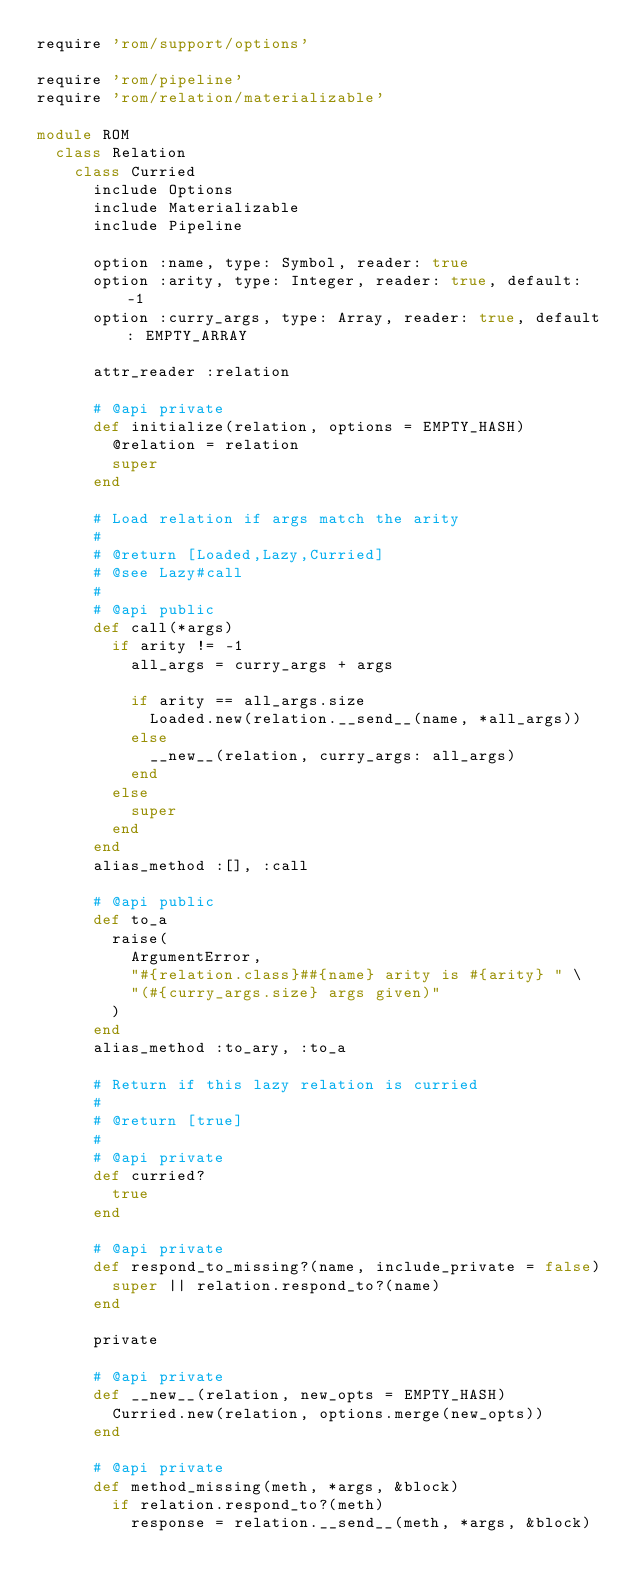<code> <loc_0><loc_0><loc_500><loc_500><_Ruby_>require 'rom/support/options'

require 'rom/pipeline'
require 'rom/relation/materializable'

module ROM
  class Relation
    class Curried
      include Options
      include Materializable
      include Pipeline

      option :name, type: Symbol, reader: true
      option :arity, type: Integer, reader: true, default: -1
      option :curry_args, type: Array, reader: true, default: EMPTY_ARRAY

      attr_reader :relation

      # @api private
      def initialize(relation, options = EMPTY_HASH)
        @relation = relation
        super
      end

      # Load relation if args match the arity
      #
      # @return [Loaded,Lazy,Curried]
      # @see Lazy#call
      #
      # @api public
      def call(*args)
        if arity != -1
          all_args = curry_args + args

          if arity == all_args.size
            Loaded.new(relation.__send__(name, *all_args))
          else
            __new__(relation, curry_args: all_args)
          end
        else
          super
        end
      end
      alias_method :[], :call

      # @api public
      def to_a
        raise(
          ArgumentError,
          "#{relation.class}##{name} arity is #{arity} " \
          "(#{curry_args.size} args given)"
        )
      end
      alias_method :to_ary, :to_a

      # Return if this lazy relation is curried
      #
      # @return [true]
      #
      # @api private
      def curried?
        true
      end

      # @api private
      def respond_to_missing?(name, include_private = false)
        super || relation.respond_to?(name)
      end

      private

      # @api private
      def __new__(relation, new_opts = EMPTY_HASH)
        Curried.new(relation, options.merge(new_opts))
      end

      # @api private
      def method_missing(meth, *args, &block)
        if relation.respond_to?(meth)
          response = relation.__send__(meth, *args, &block)
</code> 